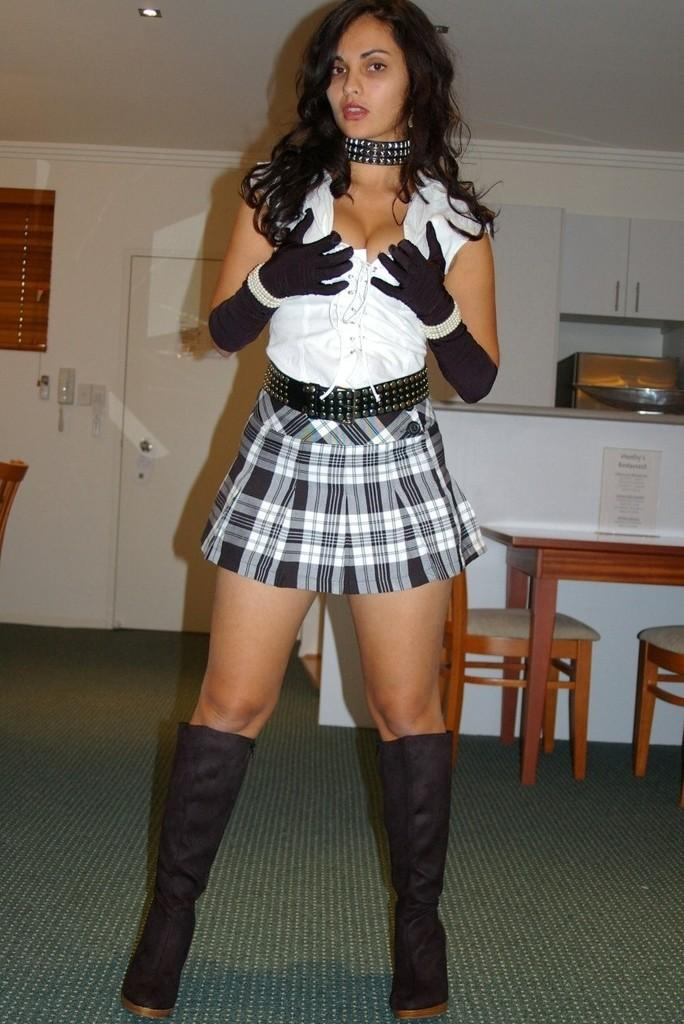Who is present in the image? There is a woman in the image. What is the woman doing in the image? The woman is standing. What is the woman wearing in the image? The woman is wearing a glucose and shoes. What can be seen in the background of the image? There is a dining table, a wooden cupboard, a door, and a wall in the background. What type of hole can be seen in the alley behind the woman in the image? There is no alley or hole present in the image; it features a woman standing in a room with a background containing a dining table, a wooden cupboard, a door, and a wall. 